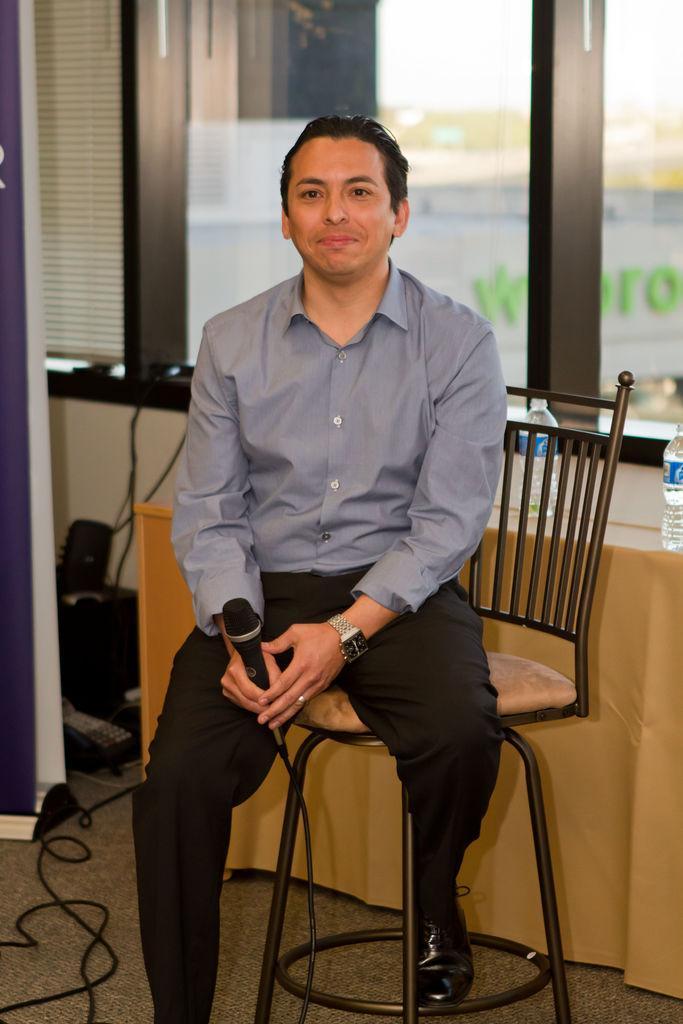Can you describe this image briefly? There is a room. He is sitting on a chair. He is wearing a watch. He is holding a mic. He is smiling. There is a table. There is a bottle on a table. We can see in background window and curtain. 